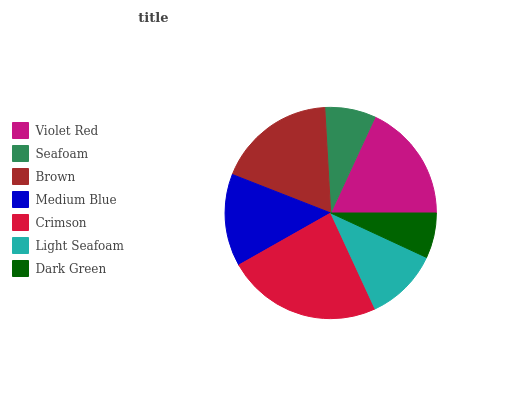Is Dark Green the minimum?
Answer yes or no. Yes. Is Crimson the maximum?
Answer yes or no. Yes. Is Seafoam the minimum?
Answer yes or no. No. Is Seafoam the maximum?
Answer yes or no. No. Is Violet Red greater than Seafoam?
Answer yes or no. Yes. Is Seafoam less than Violet Red?
Answer yes or no. Yes. Is Seafoam greater than Violet Red?
Answer yes or no. No. Is Violet Red less than Seafoam?
Answer yes or no. No. Is Medium Blue the high median?
Answer yes or no. Yes. Is Medium Blue the low median?
Answer yes or no. Yes. Is Seafoam the high median?
Answer yes or no. No. Is Dark Green the low median?
Answer yes or no. No. 